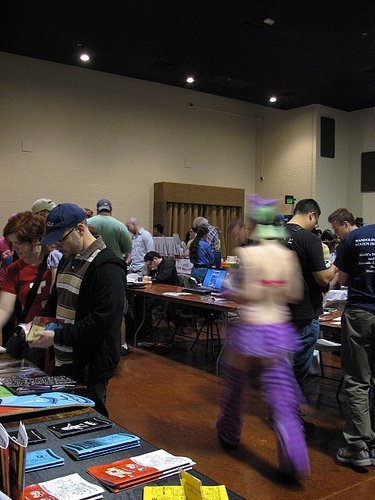<image>
Is there a laptop on the woman? No. The laptop is not positioned on the woman. They may be near each other, but the laptop is not supported by or resting on top of the woman. 